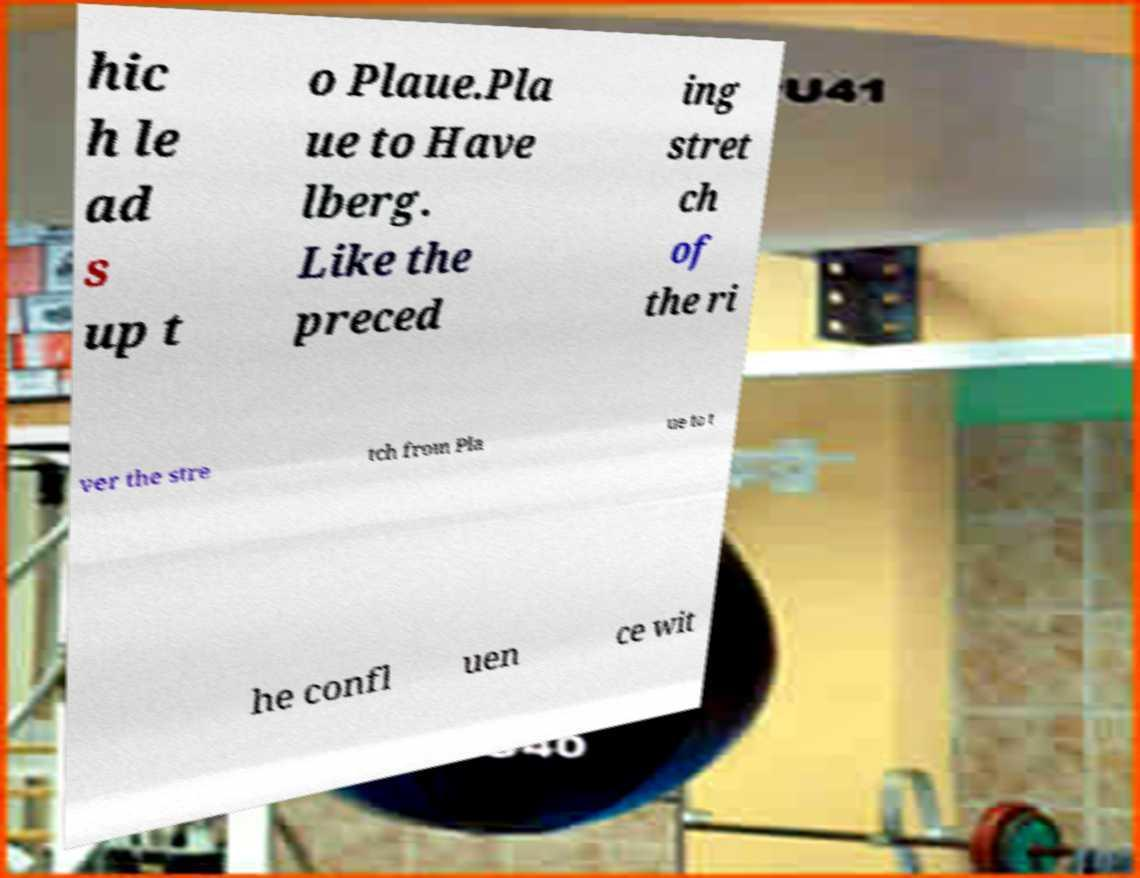Please read and relay the text visible in this image. What does it say? hic h le ad s up t o Plaue.Pla ue to Have lberg. Like the preced ing stret ch of the ri ver the stre tch from Pla ue to t he confl uen ce wit 